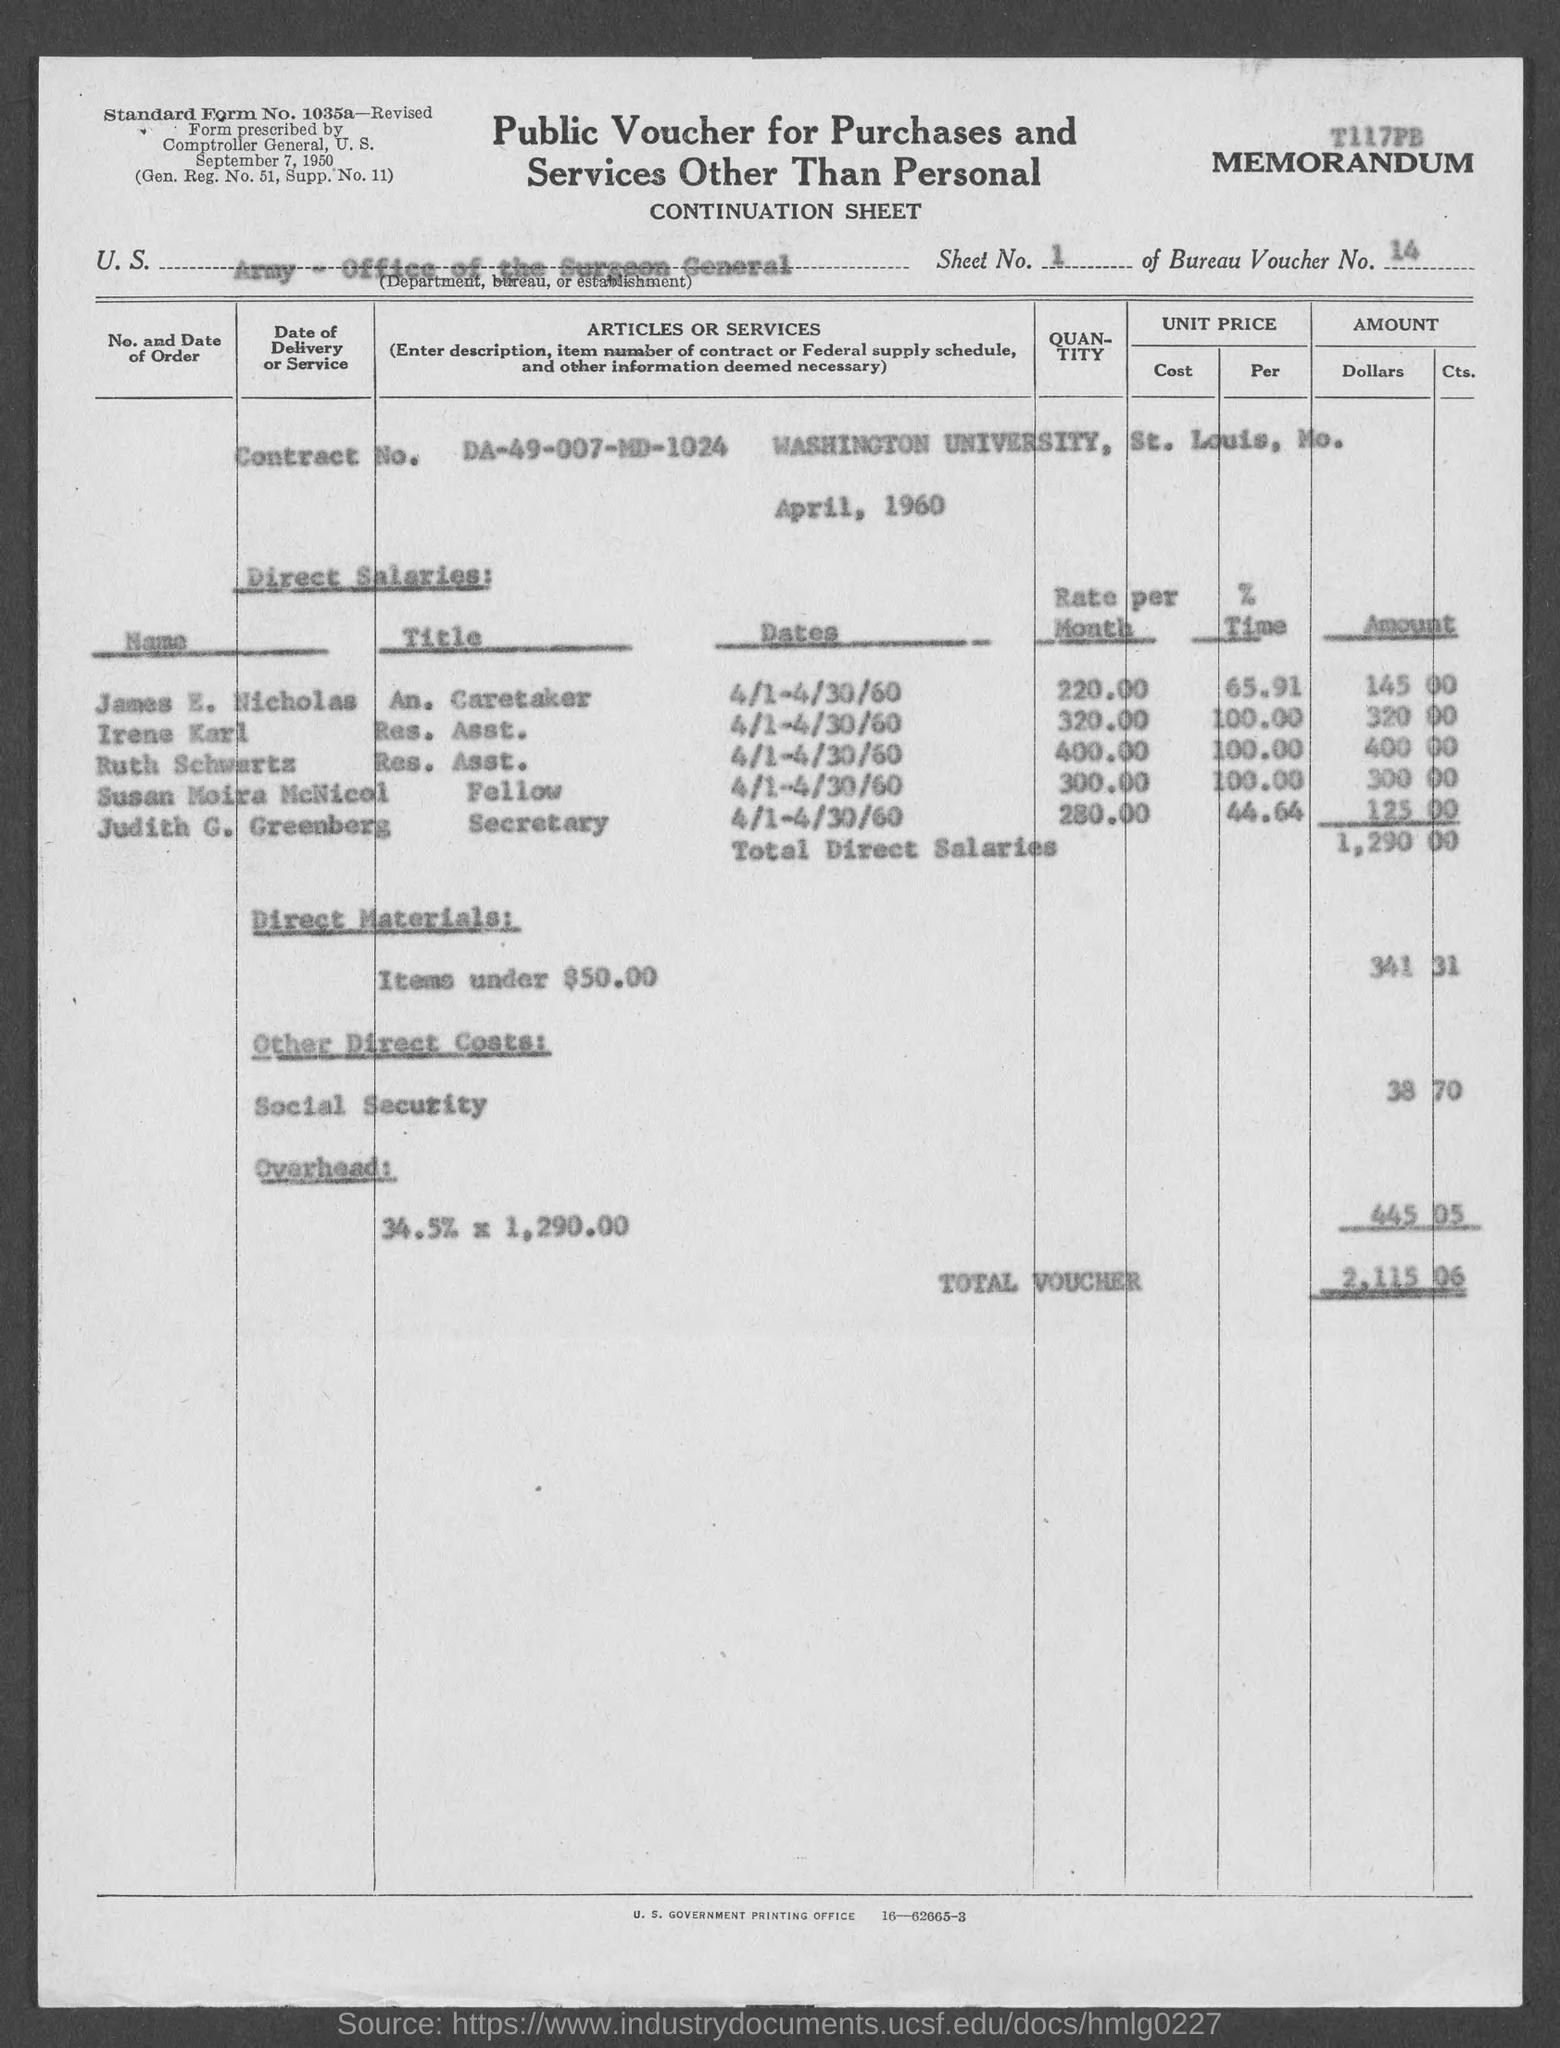List a handful of essential elements in this visual. The bureau voucher number is 14. 